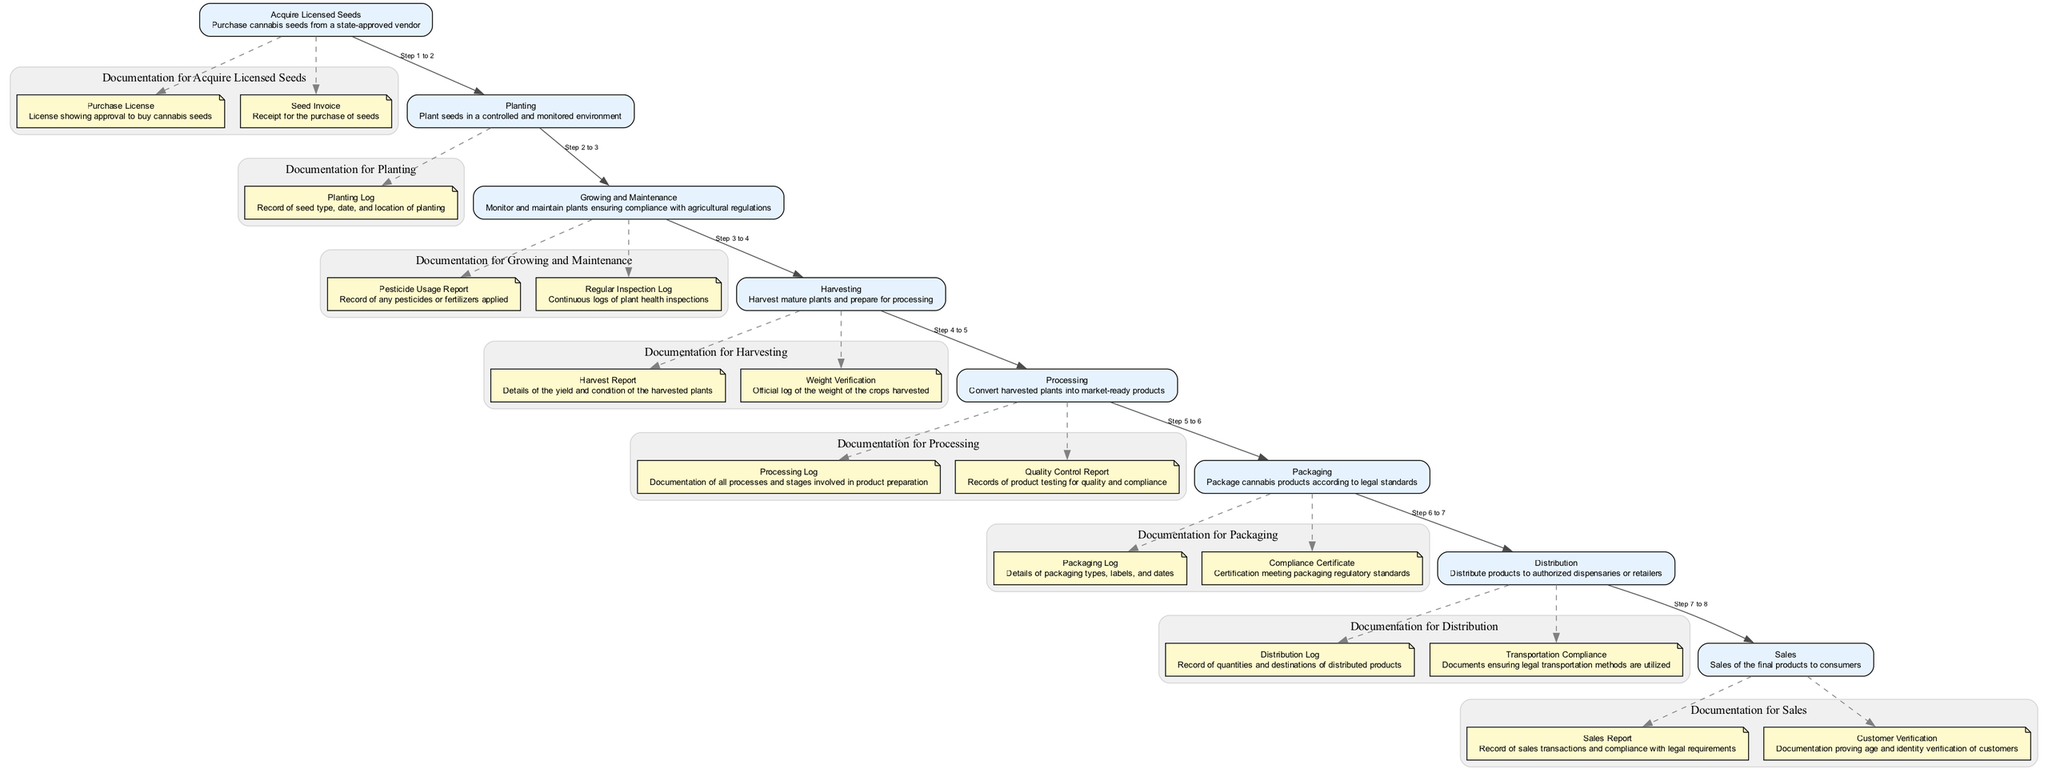What is the first step in the diagram? The first step indicated in the diagram is "Acquire Licensed Seeds." This is explicitly stated as the starting point in the flow.
Answer: Acquire Licensed Seeds How many documents are required for processing? The "Processing" step has two documents listed: "Processing Log" and "Quality Control Report." This is derived from examining the documentation for the "Processing" step.
Answer: 2 Which step comes immediately after "Harvesting"? The "Processing" step comes immediately after "Harvesting," as the diagram shows a direct connection from the "Harvesting" node to the "Processing" node.
Answer: Processing What type of report is needed during the growing and maintenance phase? A "Pesticide Usage Report" is required in the "Growing and Maintenance" phase, which is clearly listed in the documentation for that specific step.
Answer: Pesticide Usage Report How many steps are there in total? The diagram contains a total of seven steps, as you can count the listed steps from "Acquire Licensed Seeds" to "Sales."
Answer: 7 Which documentation is associated with selling cannabis products? The "Sales Report" and "Customer Verification" are the two documents associated with the "Sales" step, as seen in the documentation list under that node.
Answer: Sales Report, Customer Verification What does the "Packaging Log" detail? The "Packaging Log" details the types of packaging, labels, and dates as specified in the "Packaging" step documentation.
Answer: Packaging types, labels, dates Which step is connected to the distribution log? The "Distribution" step is connected to the "Distribution Log," as it lists this document as part of its required documentation.
Answer: Distribution What is required before harvesting & processing? The "Harvest Report" and "Weight Verification" are required before moving to the "Processing" step, as stated in the documentation of the "Harvesting" phase.
Answer: Harvest Report, Weight Verification 